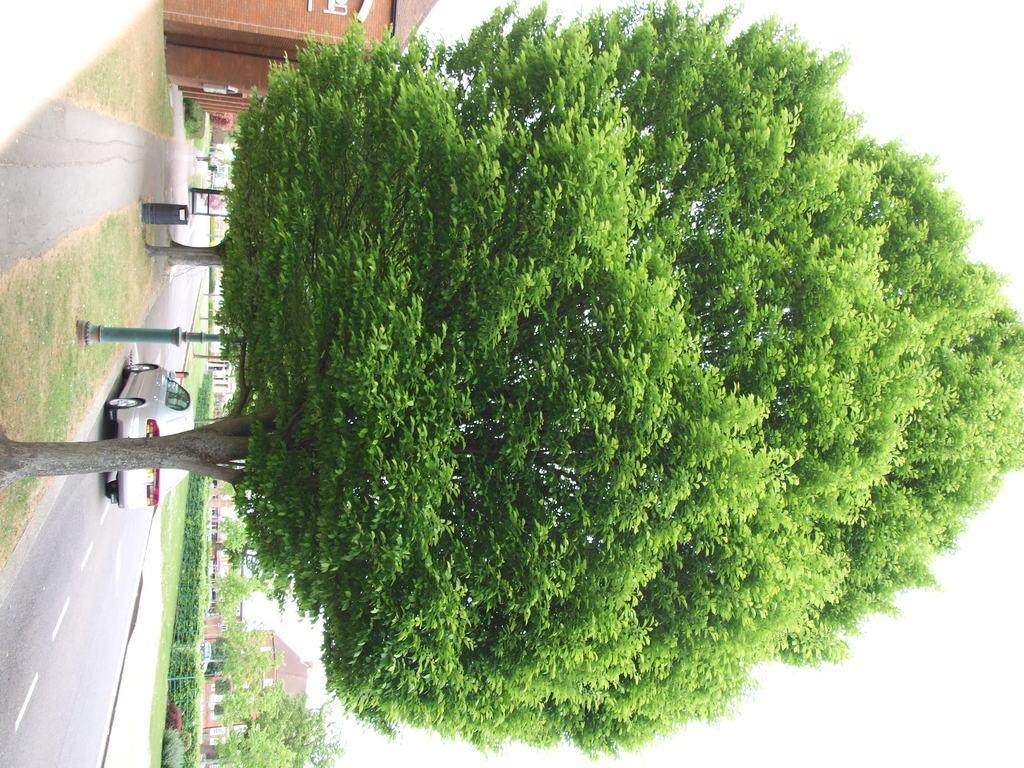How would you summarize this image in a sentence or two? In this picture we can see a tree. There is a car on the road. Behind the tree, there are some objects and a pole. At the top and bottom of the image, there are buildings. On the right side of the road, there are trees and a hedge. In the top right corner of the image, there is the sky. 